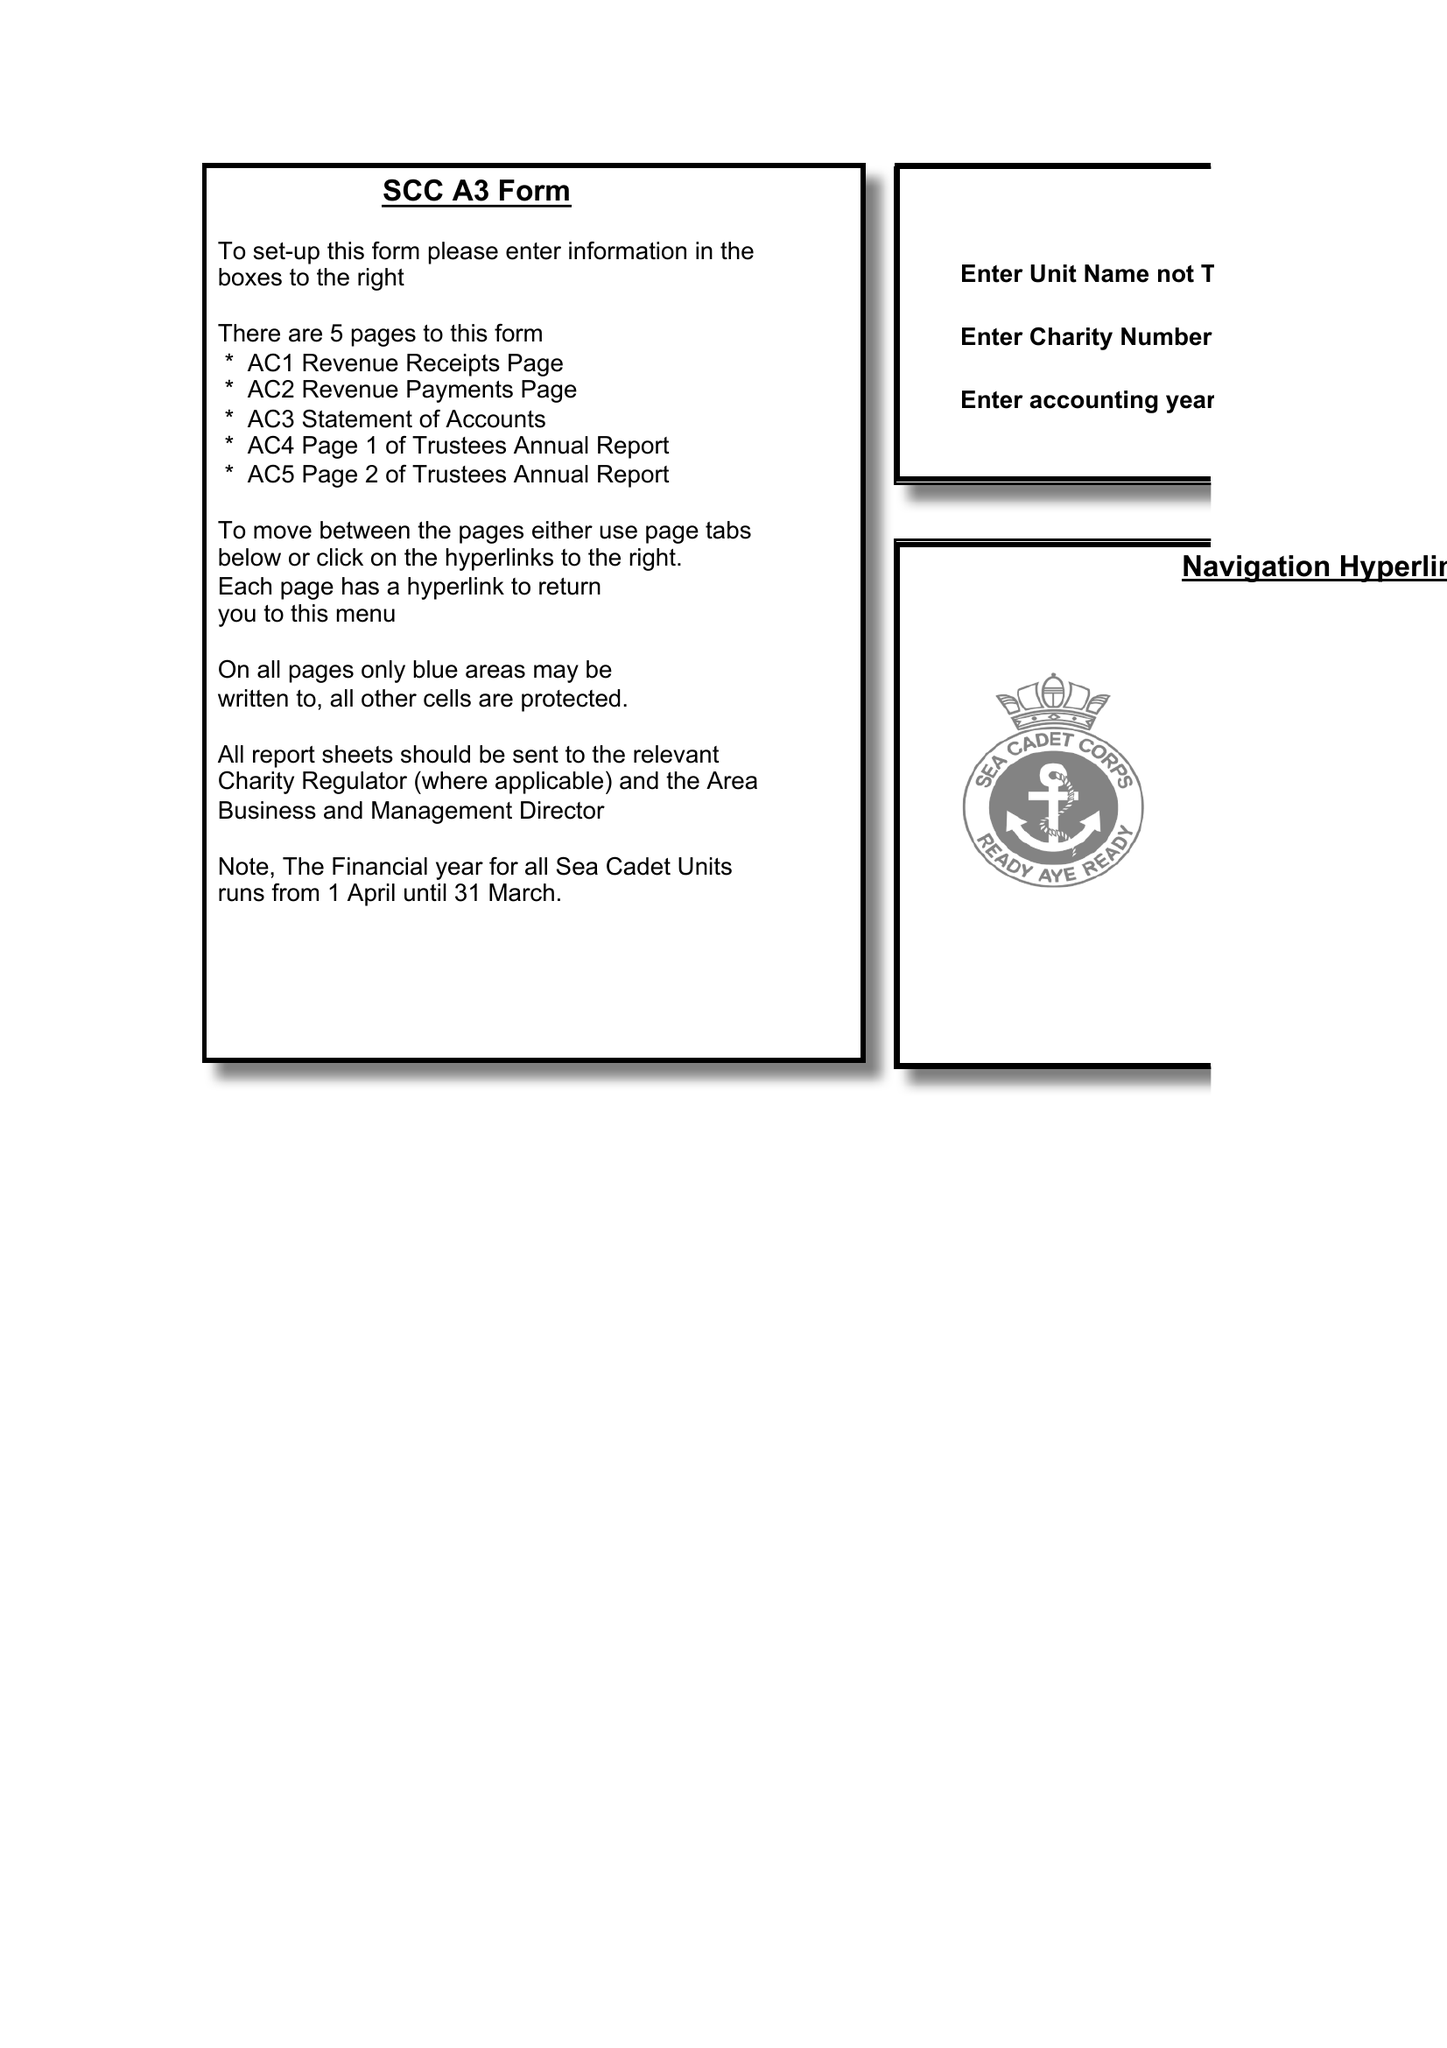What is the value for the charity_name?
Answer the question using a single word or phrase. Porthcawl Unit 438 Of The Sea Cadet Corps 